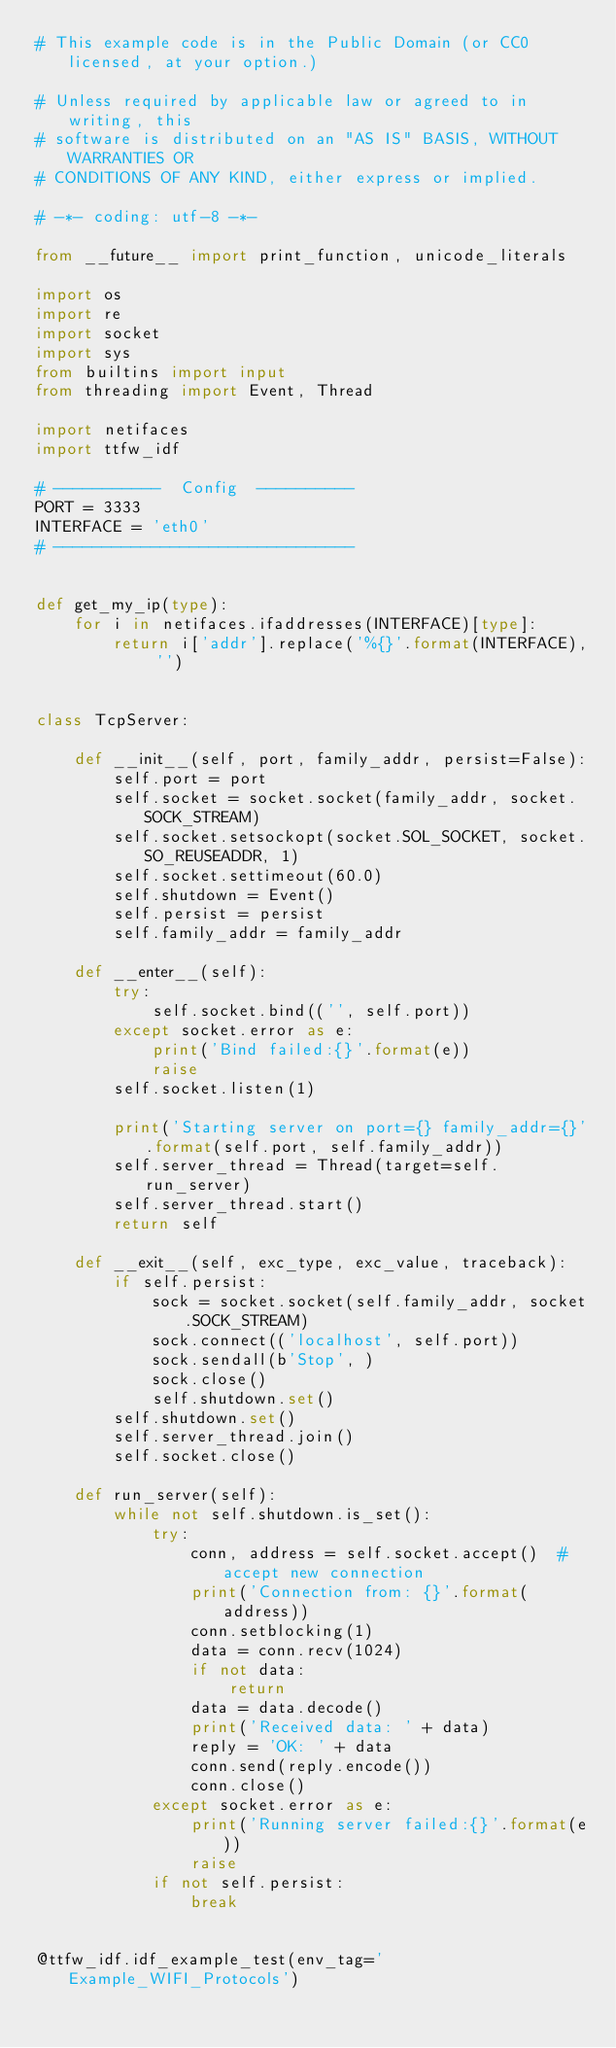<code> <loc_0><loc_0><loc_500><loc_500><_Python_># This example code is in the Public Domain (or CC0 licensed, at your option.)

# Unless required by applicable law or agreed to in writing, this
# software is distributed on an "AS IS" BASIS, WITHOUT WARRANTIES OR
# CONDITIONS OF ANY KIND, either express or implied.

# -*- coding: utf-8 -*-

from __future__ import print_function, unicode_literals

import os
import re
import socket
import sys
from builtins import input
from threading import Event, Thread

import netifaces
import ttfw_idf

# -----------  Config  ----------
PORT = 3333
INTERFACE = 'eth0'
# -------------------------------


def get_my_ip(type):
    for i in netifaces.ifaddresses(INTERFACE)[type]:
        return i['addr'].replace('%{}'.format(INTERFACE), '')


class TcpServer:

    def __init__(self, port, family_addr, persist=False):
        self.port = port
        self.socket = socket.socket(family_addr, socket.SOCK_STREAM)
        self.socket.setsockopt(socket.SOL_SOCKET, socket.SO_REUSEADDR, 1)
        self.socket.settimeout(60.0)
        self.shutdown = Event()
        self.persist = persist
        self.family_addr = family_addr

    def __enter__(self):
        try:
            self.socket.bind(('', self.port))
        except socket.error as e:
            print('Bind failed:{}'.format(e))
            raise
        self.socket.listen(1)

        print('Starting server on port={} family_addr={}'.format(self.port, self.family_addr))
        self.server_thread = Thread(target=self.run_server)
        self.server_thread.start()
        return self

    def __exit__(self, exc_type, exc_value, traceback):
        if self.persist:
            sock = socket.socket(self.family_addr, socket.SOCK_STREAM)
            sock.connect(('localhost', self.port))
            sock.sendall(b'Stop', )
            sock.close()
            self.shutdown.set()
        self.shutdown.set()
        self.server_thread.join()
        self.socket.close()

    def run_server(self):
        while not self.shutdown.is_set():
            try:
                conn, address = self.socket.accept()  # accept new connection
                print('Connection from: {}'.format(address))
                conn.setblocking(1)
                data = conn.recv(1024)
                if not data:
                    return
                data = data.decode()
                print('Received data: ' + data)
                reply = 'OK: ' + data
                conn.send(reply.encode())
                conn.close()
            except socket.error as e:
                print('Running server failed:{}'.format(e))
                raise
            if not self.persist:
                break


@ttfw_idf.idf_example_test(env_tag='Example_WIFI_Protocols')</code> 